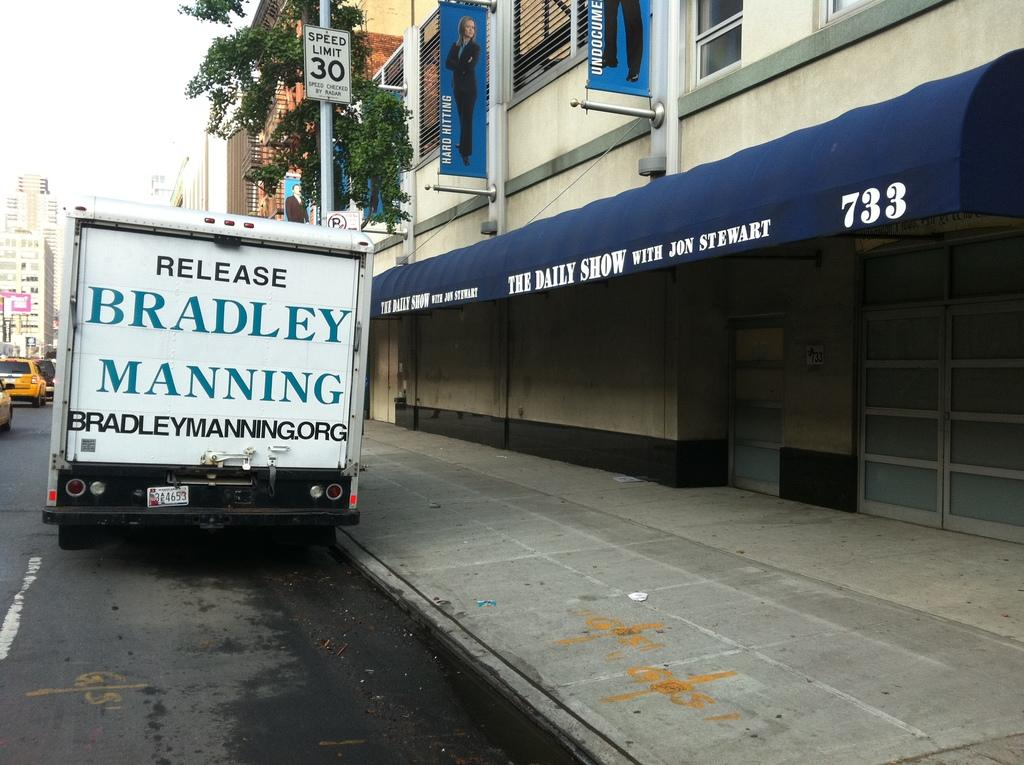What type of structures can be seen in the image? There are buildings in the image. What natural element is present in the image? There is a tree in the image. What mode of transportation can be seen on the road in the image? Vehicles are present on the road in the image. What are the poles with boards used for in the image? The poles with boards might be used for signage or advertisements in the image. What can be seen in the background of the image? The sky is visible in the background of the image. What type of jelly is being used to hold the buildings together in the image? There is no jelly present in the image; the buildings are held together by their structural components. Can you see a loaf of bread in the image? There is no loaf of bread present in the image. 